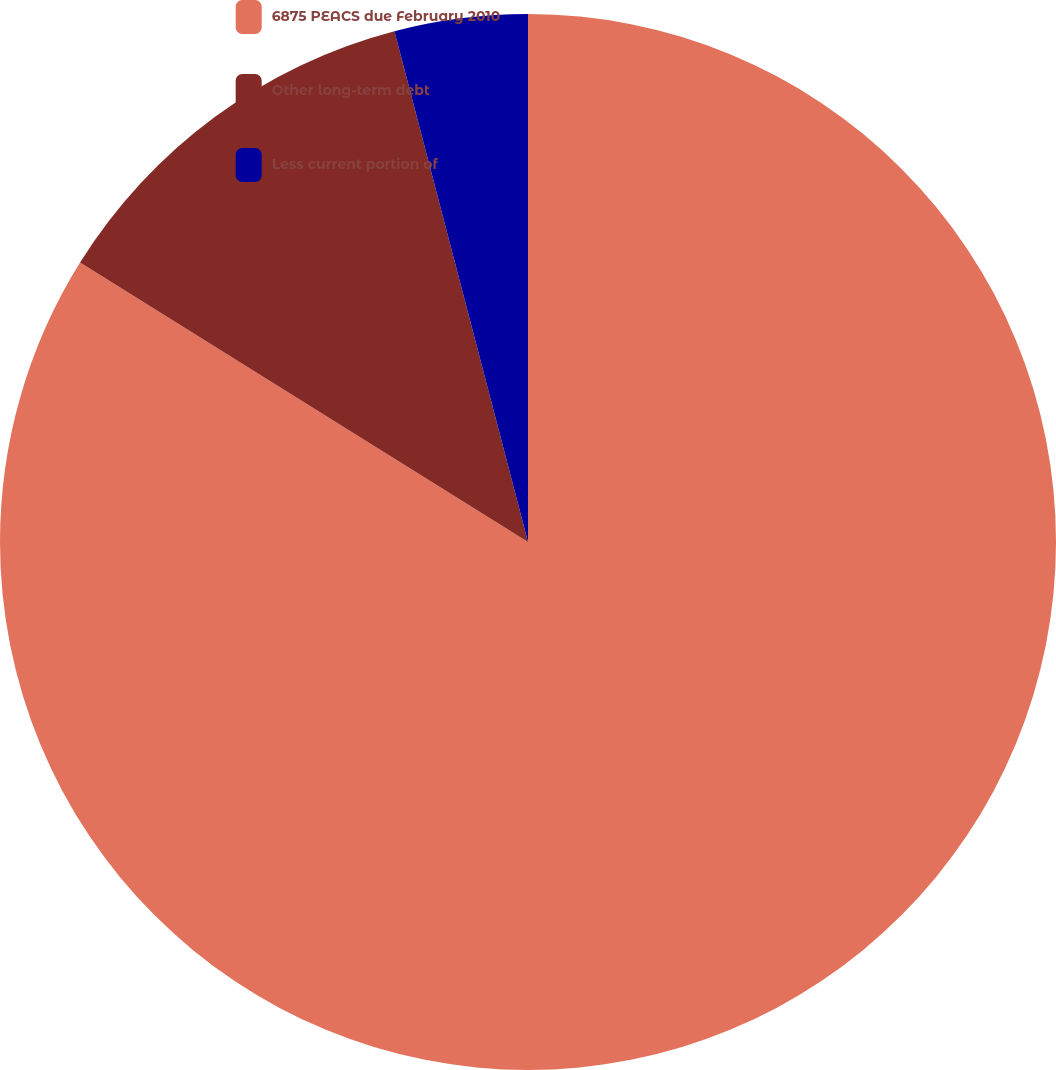Convert chart to OTSL. <chart><loc_0><loc_0><loc_500><loc_500><pie_chart><fcel>6875 PEACS due February 2010<fcel>Other long-term debt<fcel>Less current portion of<nl><fcel>83.87%<fcel>12.05%<fcel>4.07%<nl></chart> 